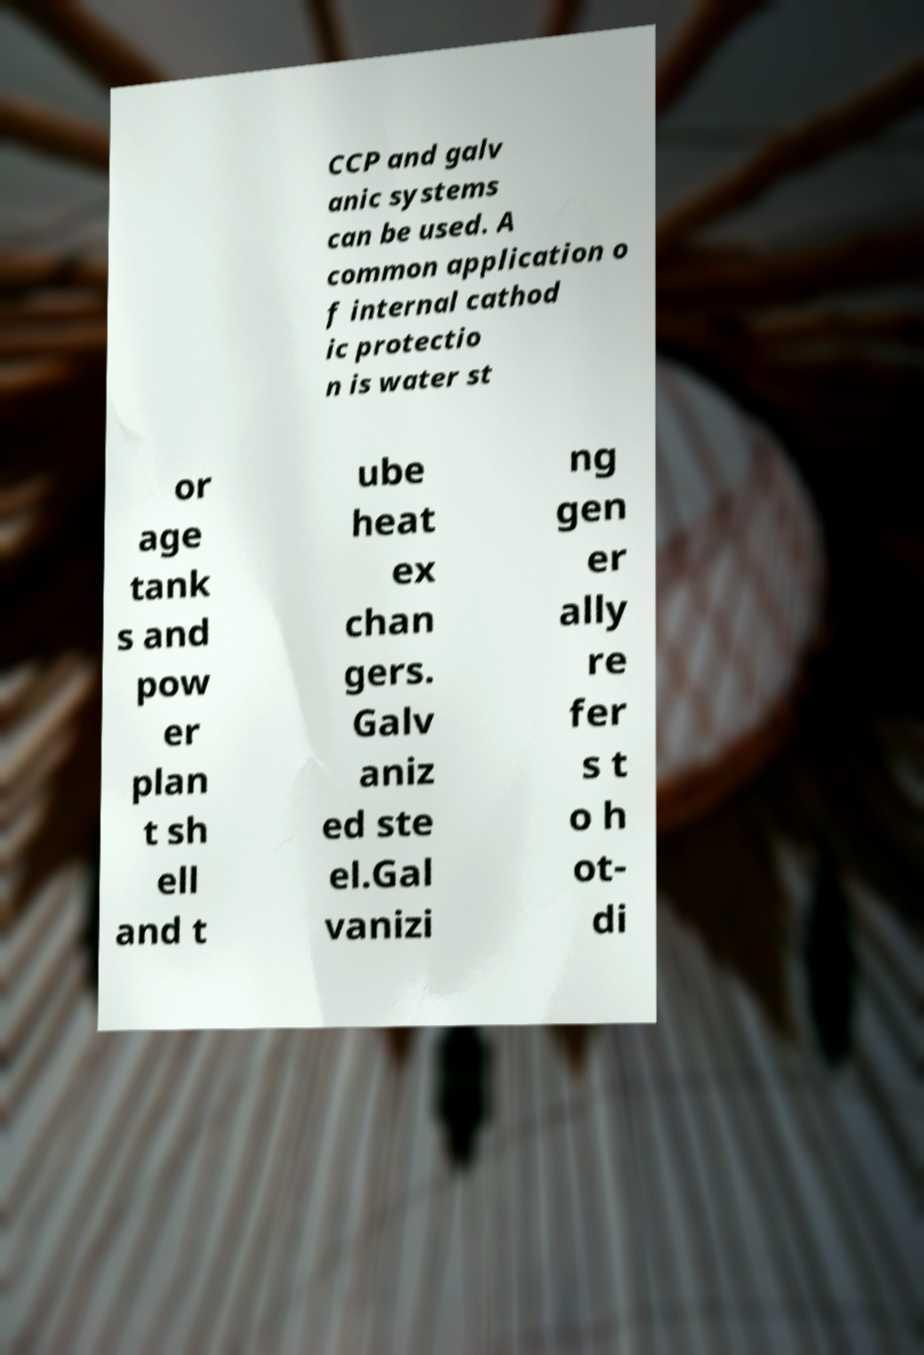Can you read and provide the text displayed in the image?This photo seems to have some interesting text. Can you extract and type it out for me? CCP and galv anic systems can be used. A common application o f internal cathod ic protectio n is water st or age tank s and pow er plan t sh ell and t ube heat ex chan gers. Galv aniz ed ste el.Gal vanizi ng gen er ally re fer s t o h ot- di 